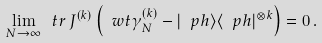Convert formula to latex. <formula><loc_0><loc_0><loc_500><loc_500>\lim _ { N \to \infty } \ t r \, J ^ { ( k ) } \left ( \ w t \gamma ^ { ( k ) } _ { N } - | \ p h \rangle \langle \ p h | ^ { \otimes k } \right ) = 0 \, .</formula> 